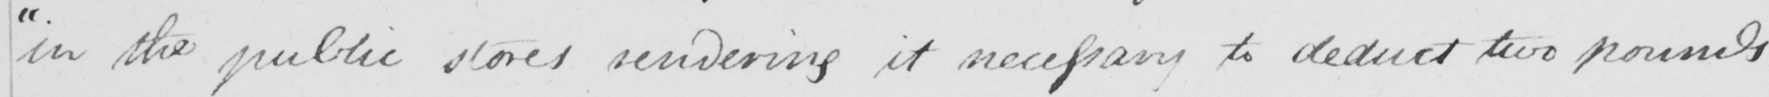Can you read and transcribe this handwriting? " in the public stores rendering it necessary to deduct two pounds 